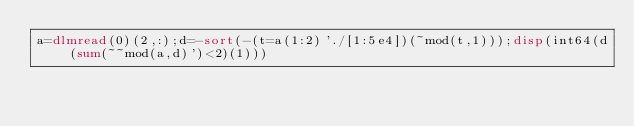<code> <loc_0><loc_0><loc_500><loc_500><_Octave_>a=dlmread(0)(2,:);d=-sort(-(t=a(1:2)'./[1:5e4])(~mod(t,1)));disp(int64(d(sum(~~mod(a,d)')<2)(1)))</code> 